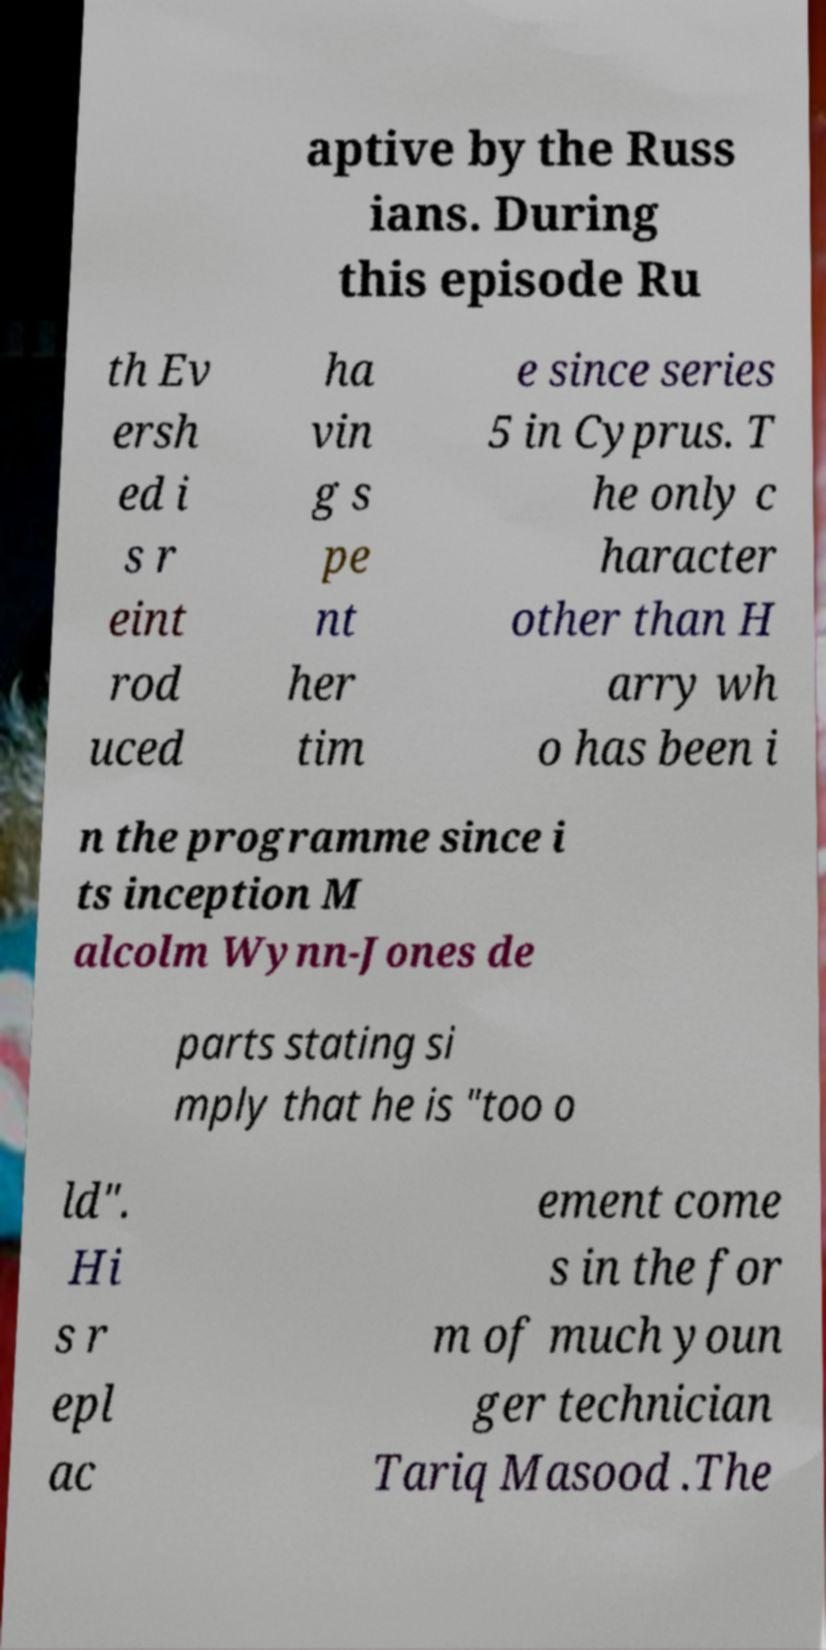Could you extract and type out the text from this image? aptive by the Russ ians. During this episode Ru th Ev ersh ed i s r eint rod uced ha vin g s pe nt her tim e since series 5 in Cyprus. T he only c haracter other than H arry wh o has been i n the programme since i ts inception M alcolm Wynn-Jones de parts stating si mply that he is "too o ld". Hi s r epl ac ement come s in the for m of much youn ger technician Tariq Masood .The 